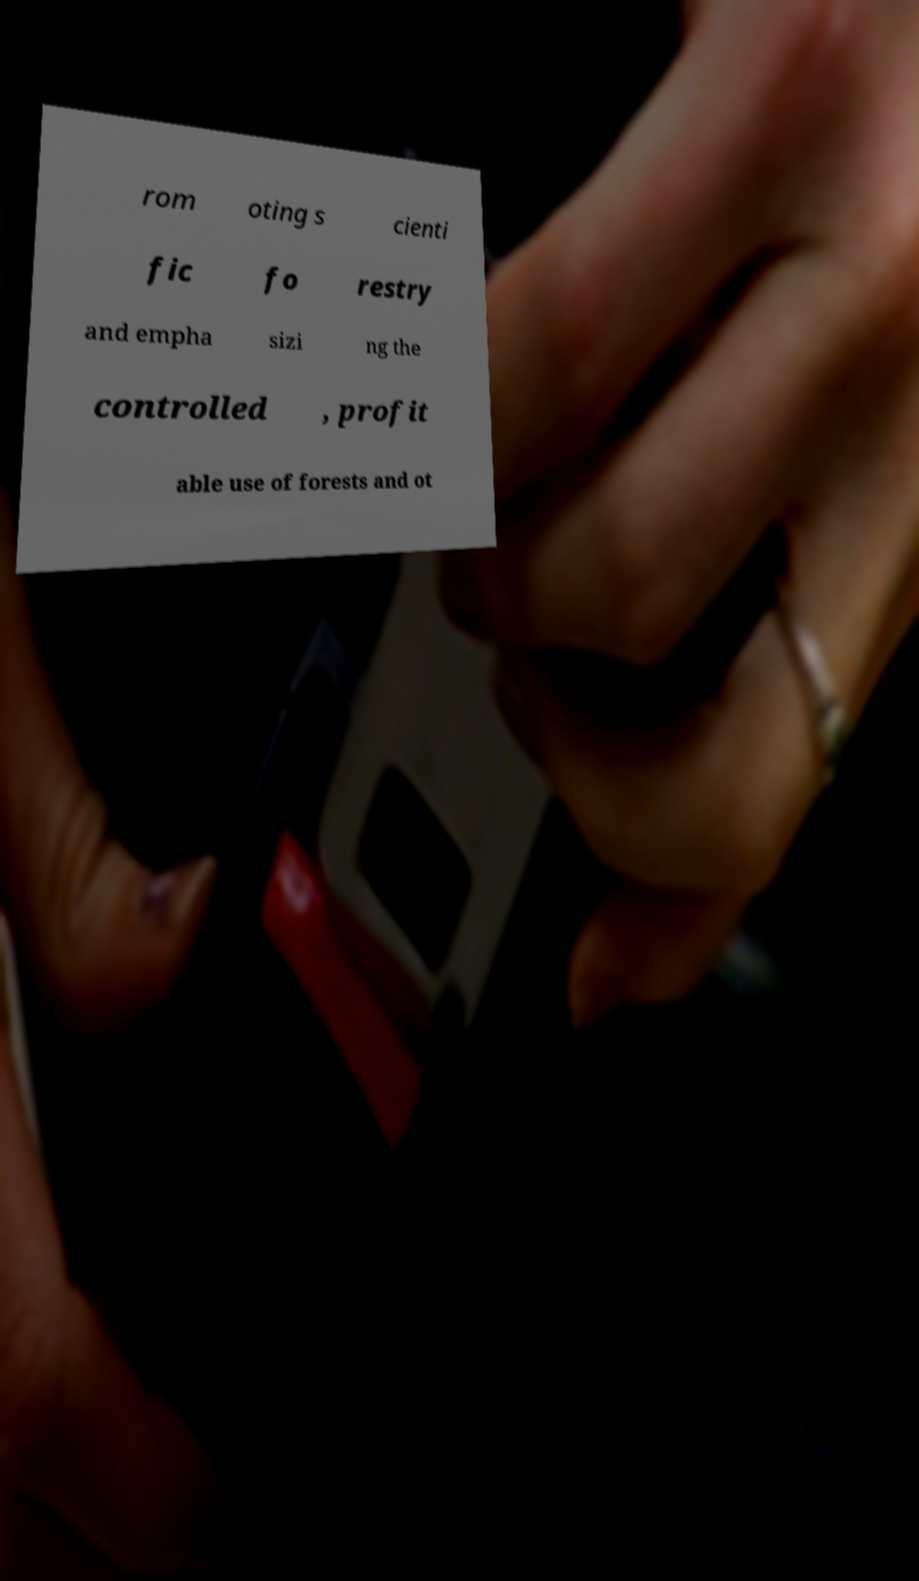Can you read and provide the text displayed in the image?This photo seems to have some interesting text. Can you extract and type it out for me? rom oting s cienti fic fo restry and empha sizi ng the controlled , profit able use of forests and ot 